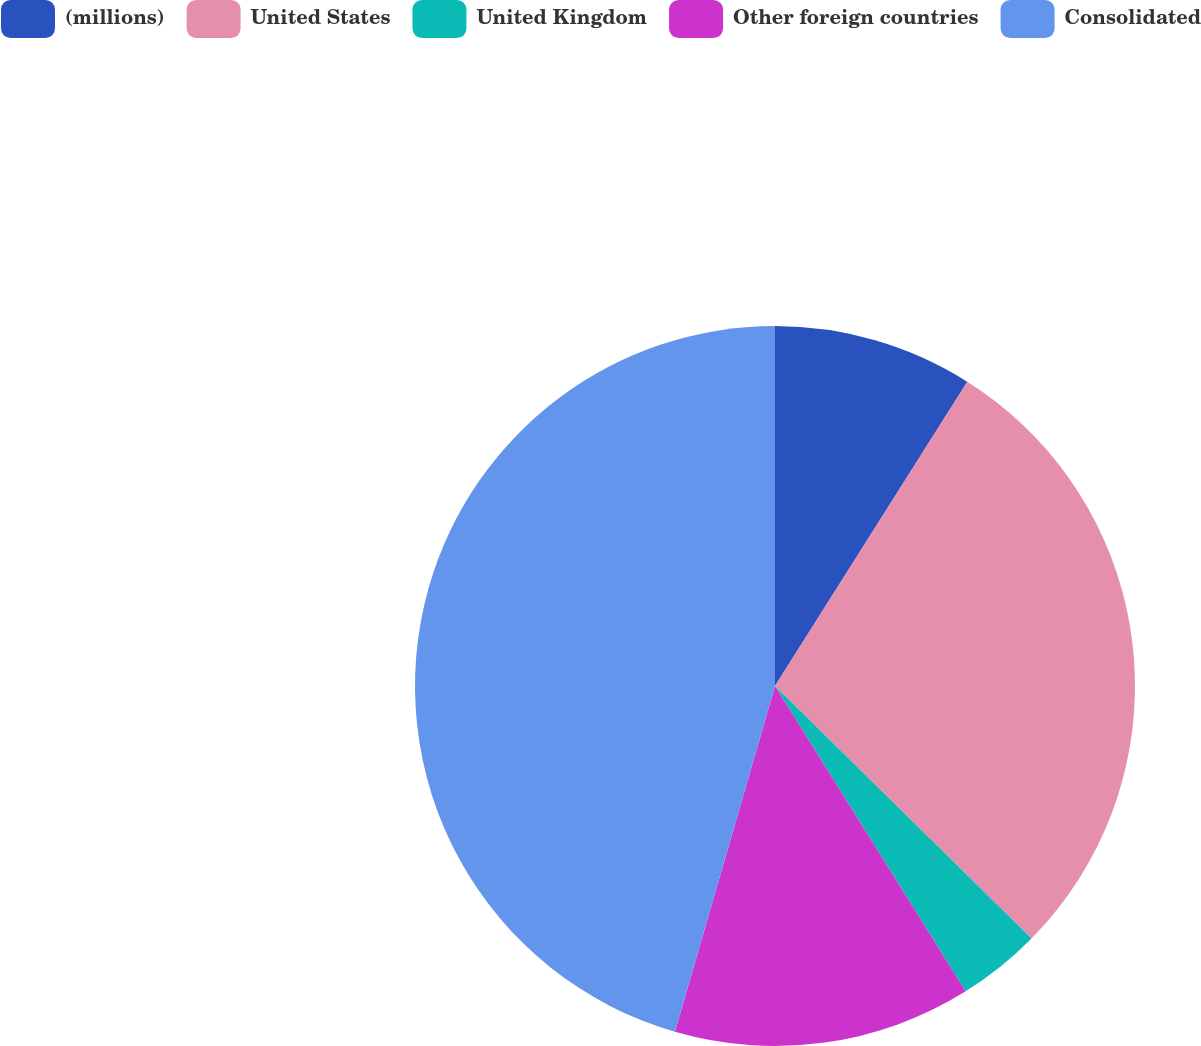<chart> <loc_0><loc_0><loc_500><loc_500><pie_chart><fcel>(millions)<fcel>United States<fcel>United Kingdom<fcel>Other foreign countries<fcel>Consolidated<nl><fcel>8.97%<fcel>28.41%<fcel>3.74%<fcel>13.37%<fcel>45.52%<nl></chart> 